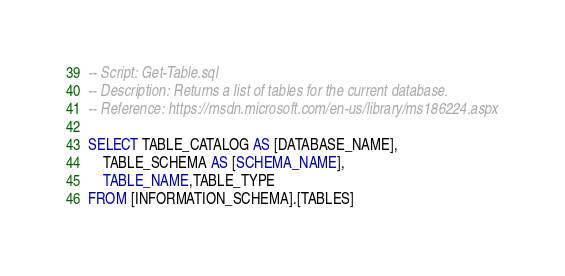<code> <loc_0><loc_0><loc_500><loc_500><_SQL_>-- Script: Get-Table.sql
-- Description: Returns a list of tables for the current database.
-- Reference: https://msdn.microsoft.com/en-us/library/ms186224.aspx

SELECT TABLE_CATALOG AS [DATABASE_NAME],
	TABLE_SCHEMA AS [SCHEMA_NAME],
	TABLE_NAME,TABLE_TYPE
FROM [INFORMATION_SCHEMA].[TABLES]</code> 